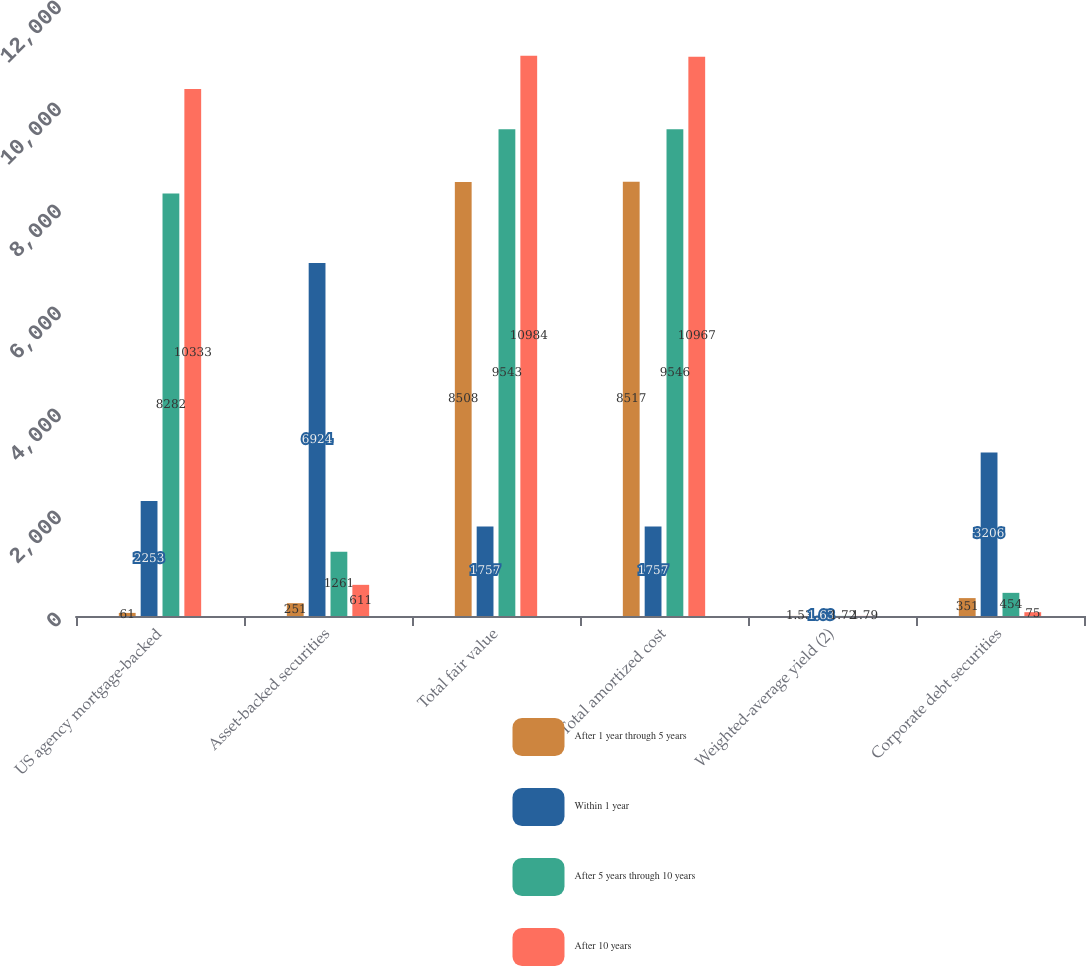Convert chart. <chart><loc_0><loc_0><loc_500><loc_500><stacked_bar_chart><ecel><fcel>US agency mortgage-backed<fcel>Asset-backed securities<fcel>Total fair value<fcel>Total amortized cost<fcel>Weighted-average yield (2)<fcel>Corporate debt securities<nl><fcel>After 1 year through 5 years<fcel>61<fcel>251<fcel>8508<fcel>8517<fcel>1.53<fcel>351<nl><fcel>Within 1 year<fcel>2253<fcel>6924<fcel>1757<fcel>1757<fcel>1.63<fcel>3206<nl><fcel>After 5 years through 10 years<fcel>8282<fcel>1261<fcel>9543<fcel>9546<fcel>1.72<fcel>454<nl><fcel>After 10 years<fcel>10333<fcel>611<fcel>10984<fcel>10967<fcel>1.79<fcel>75<nl></chart> 